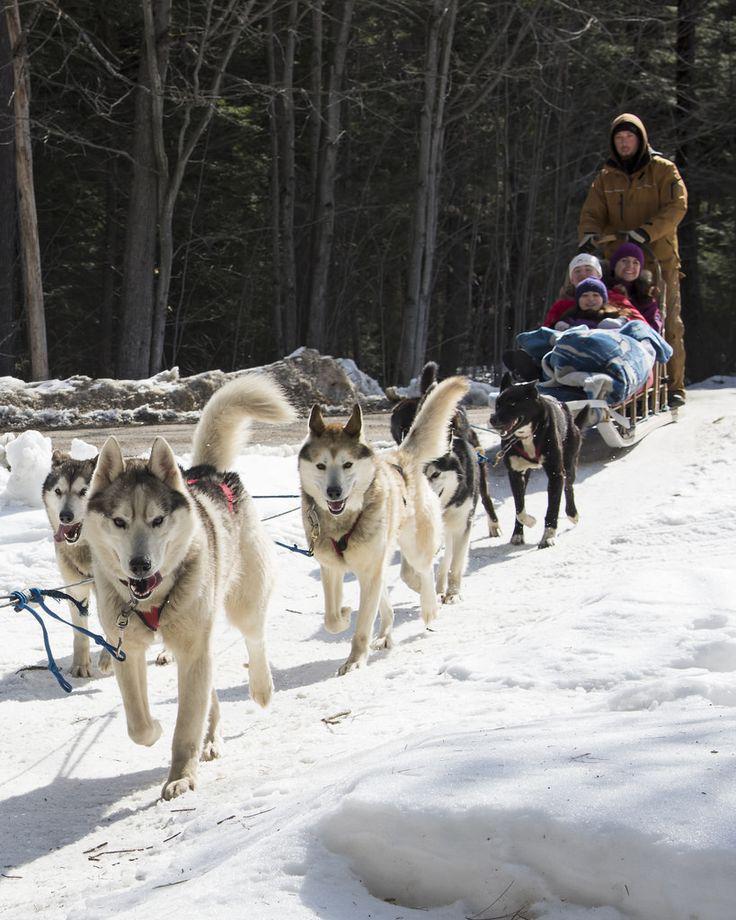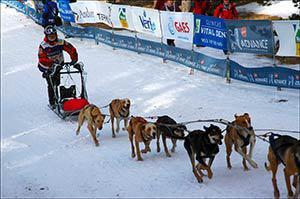The first image is the image on the left, the second image is the image on the right. For the images displayed, is the sentence "A person wearing a blue jacket is driving the sled in the photo on the right.." factually correct? Answer yes or no. No. The first image is the image on the left, the second image is the image on the right. Given the left and right images, does the statement "One of the pictures shows more than one human being pulled by the dogs." hold true? Answer yes or no. Yes. The first image is the image on the left, the second image is the image on the right. Given the left and right images, does the statement "There are four dogs on the left image" hold true? Answer yes or no. No. 